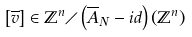<formula> <loc_0><loc_0><loc_500><loc_500>\left [ \overline { v } \right ] \in \mathbb { Z } ^ { n } \diagup \left ( \overline { A } _ { N } - i d \right ) \left ( \mathbb { Z } ^ { n } \right )</formula> 